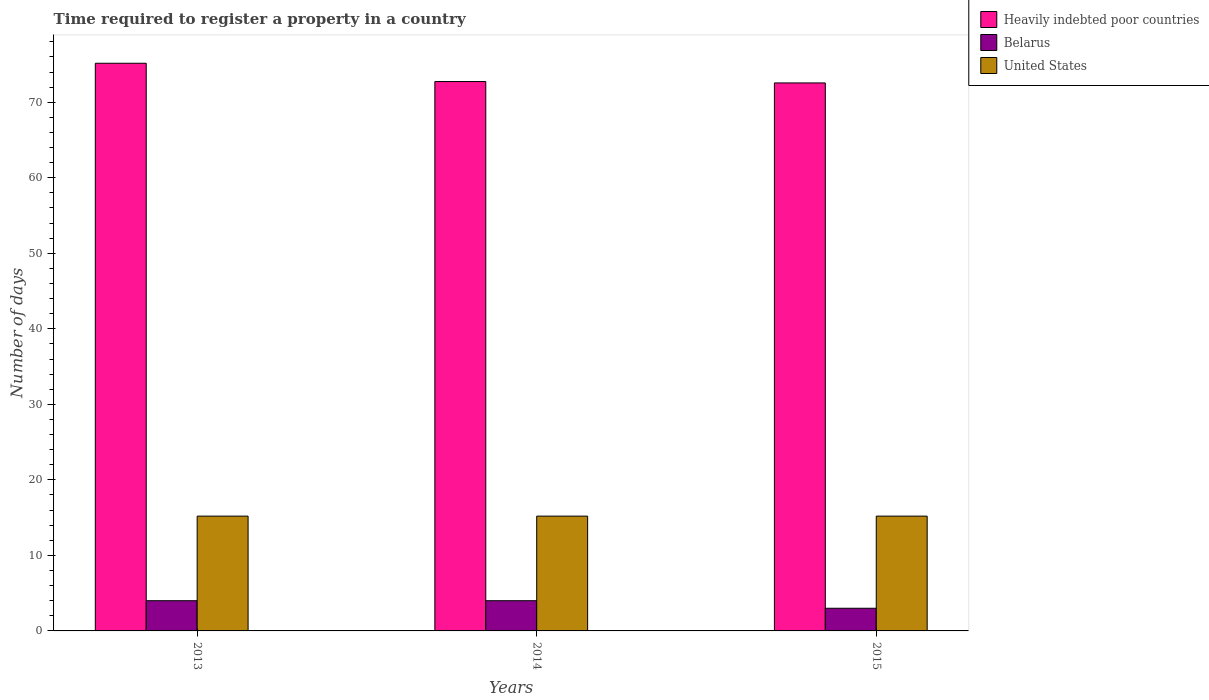How many different coloured bars are there?
Keep it short and to the point. 3. How many groups of bars are there?
Provide a short and direct response. 3. Are the number of bars on each tick of the X-axis equal?
Provide a succinct answer. Yes. How many bars are there on the 1st tick from the left?
Your answer should be very brief. 3. How many bars are there on the 3rd tick from the right?
Offer a very short reply. 3. What is the label of the 2nd group of bars from the left?
Offer a terse response. 2014. What is the number of days required to register a property in United States in 2013?
Ensure brevity in your answer.  15.2. Across all years, what is the maximum number of days required to register a property in Belarus?
Keep it short and to the point. 4. In which year was the number of days required to register a property in Belarus minimum?
Provide a short and direct response. 2015. What is the total number of days required to register a property in Heavily indebted poor countries in the graph?
Your response must be concise. 220.45. What is the difference between the number of days required to register a property in Heavily indebted poor countries in 2013 and that in 2015?
Give a very brief answer. 2.61. What is the difference between the number of days required to register a property in United States in 2014 and the number of days required to register a property in Heavily indebted poor countries in 2013?
Keep it short and to the point. -59.96. What is the average number of days required to register a property in Belarus per year?
Give a very brief answer. 3.67. In how many years, is the number of days required to register a property in Belarus greater than 8 days?
Offer a terse response. 0. Is the difference between the number of days required to register a property in United States in 2013 and 2015 greater than the difference between the number of days required to register a property in Belarus in 2013 and 2015?
Give a very brief answer. No. What is the difference between the highest and the second highest number of days required to register a property in Heavily indebted poor countries?
Provide a short and direct response. 2.42. What is the difference between the highest and the lowest number of days required to register a property in Heavily indebted poor countries?
Provide a succinct answer. 2.61. Is the sum of the number of days required to register a property in United States in 2013 and 2014 greater than the maximum number of days required to register a property in Heavily indebted poor countries across all years?
Your answer should be compact. No. What does the 1st bar from the left in 2015 represents?
Provide a short and direct response. Heavily indebted poor countries. What does the 1st bar from the right in 2013 represents?
Make the answer very short. United States. What is the difference between two consecutive major ticks on the Y-axis?
Offer a very short reply. 10. Where does the legend appear in the graph?
Offer a terse response. Top right. How are the legend labels stacked?
Your answer should be very brief. Vertical. What is the title of the graph?
Keep it short and to the point. Time required to register a property in a country. What is the label or title of the Y-axis?
Provide a short and direct response. Number of days. What is the Number of days of Heavily indebted poor countries in 2013?
Provide a short and direct response. 75.16. What is the Number of days of Belarus in 2013?
Your answer should be very brief. 4. What is the Number of days in Heavily indebted poor countries in 2014?
Provide a succinct answer. 72.74. What is the Number of days of United States in 2014?
Your response must be concise. 15.2. What is the Number of days of Heavily indebted poor countries in 2015?
Your answer should be compact. 72.55. What is the Number of days in Belarus in 2015?
Offer a terse response. 3. Across all years, what is the maximum Number of days of Heavily indebted poor countries?
Provide a succinct answer. 75.16. Across all years, what is the minimum Number of days of Heavily indebted poor countries?
Your answer should be compact. 72.55. Across all years, what is the minimum Number of days in Belarus?
Ensure brevity in your answer.  3. What is the total Number of days in Heavily indebted poor countries in the graph?
Offer a terse response. 220.45. What is the total Number of days in Belarus in the graph?
Your answer should be very brief. 11. What is the total Number of days in United States in the graph?
Your answer should be very brief. 45.6. What is the difference between the Number of days of Heavily indebted poor countries in 2013 and that in 2014?
Offer a terse response. 2.42. What is the difference between the Number of days in Belarus in 2013 and that in 2014?
Your answer should be very brief. 0. What is the difference between the Number of days of Heavily indebted poor countries in 2013 and that in 2015?
Keep it short and to the point. 2.61. What is the difference between the Number of days of Belarus in 2013 and that in 2015?
Your response must be concise. 1. What is the difference between the Number of days of Heavily indebted poor countries in 2014 and that in 2015?
Give a very brief answer. 0.18. What is the difference between the Number of days in Heavily indebted poor countries in 2013 and the Number of days in Belarus in 2014?
Ensure brevity in your answer.  71.16. What is the difference between the Number of days in Heavily indebted poor countries in 2013 and the Number of days in United States in 2014?
Offer a very short reply. 59.96. What is the difference between the Number of days of Heavily indebted poor countries in 2013 and the Number of days of Belarus in 2015?
Offer a terse response. 72.16. What is the difference between the Number of days of Heavily indebted poor countries in 2013 and the Number of days of United States in 2015?
Keep it short and to the point. 59.96. What is the difference between the Number of days in Belarus in 2013 and the Number of days in United States in 2015?
Provide a short and direct response. -11.2. What is the difference between the Number of days in Heavily indebted poor countries in 2014 and the Number of days in Belarus in 2015?
Your response must be concise. 69.74. What is the difference between the Number of days in Heavily indebted poor countries in 2014 and the Number of days in United States in 2015?
Ensure brevity in your answer.  57.54. What is the difference between the Number of days of Belarus in 2014 and the Number of days of United States in 2015?
Keep it short and to the point. -11.2. What is the average Number of days in Heavily indebted poor countries per year?
Provide a succinct answer. 73.48. What is the average Number of days of Belarus per year?
Give a very brief answer. 3.67. In the year 2013, what is the difference between the Number of days in Heavily indebted poor countries and Number of days in Belarus?
Offer a terse response. 71.16. In the year 2013, what is the difference between the Number of days of Heavily indebted poor countries and Number of days of United States?
Keep it short and to the point. 59.96. In the year 2013, what is the difference between the Number of days in Belarus and Number of days in United States?
Your answer should be compact. -11.2. In the year 2014, what is the difference between the Number of days of Heavily indebted poor countries and Number of days of Belarus?
Offer a terse response. 68.74. In the year 2014, what is the difference between the Number of days of Heavily indebted poor countries and Number of days of United States?
Your answer should be very brief. 57.54. In the year 2014, what is the difference between the Number of days in Belarus and Number of days in United States?
Your answer should be very brief. -11.2. In the year 2015, what is the difference between the Number of days of Heavily indebted poor countries and Number of days of Belarus?
Provide a short and direct response. 69.55. In the year 2015, what is the difference between the Number of days in Heavily indebted poor countries and Number of days in United States?
Keep it short and to the point. 57.35. What is the ratio of the Number of days of Heavily indebted poor countries in 2013 to that in 2014?
Provide a succinct answer. 1.03. What is the ratio of the Number of days in United States in 2013 to that in 2014?
Make the answer very short. 1. What is the ratio of the Number of days in Heavily indebted poor countries in 2013 to that in 2015?
Offer a terse response. 1.04. What is the ratio of the Number of days in Heavily indebted poor countries in 2014 to that in 2015?
Give a very brief answer. 1. What is the ratio of the Number of days in Belarus in 2014 to that in 2015?
Make the answer very short. 1.33. What is the difference between the highest and the second highest Number of days in Heavily indebted poor countries?
Keep it short and to the point. 2.42. What is the difference between the highest and the second highest Number of days in United States?
Provide a short and direct response. 0. What is the difference between the highest and the lowest Number of days in Heavily indebted poor countries?
Your response must be concise. 2.61. What is the difference between the highest and the lowest Number of days in Belarus?
Ensure brevity in your answer.  1. What is the difference between the highest and the lowest Number of days in United States?
Offer a very short reply. 0. 